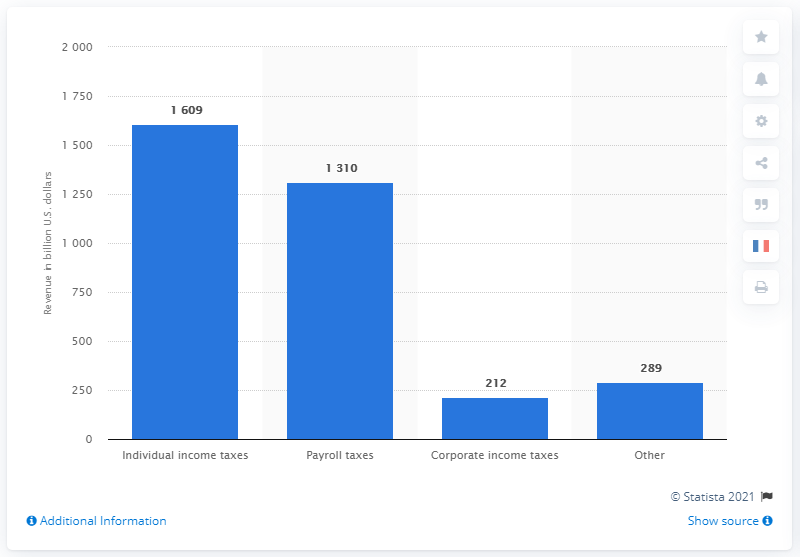Outline some significant characteristics in this image. According to the data provided, individual income taxes in 2020 totaled 1609 dollars. 